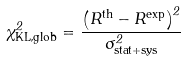<formula> <loc_0><loc_0><loc_500><loc_500>\chi ^ { 2 } _ { \text {KL,glob} } = \frac { \left ( R ^ { \text {th} } - R ^ { \text {exp} } \right ) ^ { 2 } } { \sigma _ { \text {stat+sys} } ^ { 2 } }</formula> 